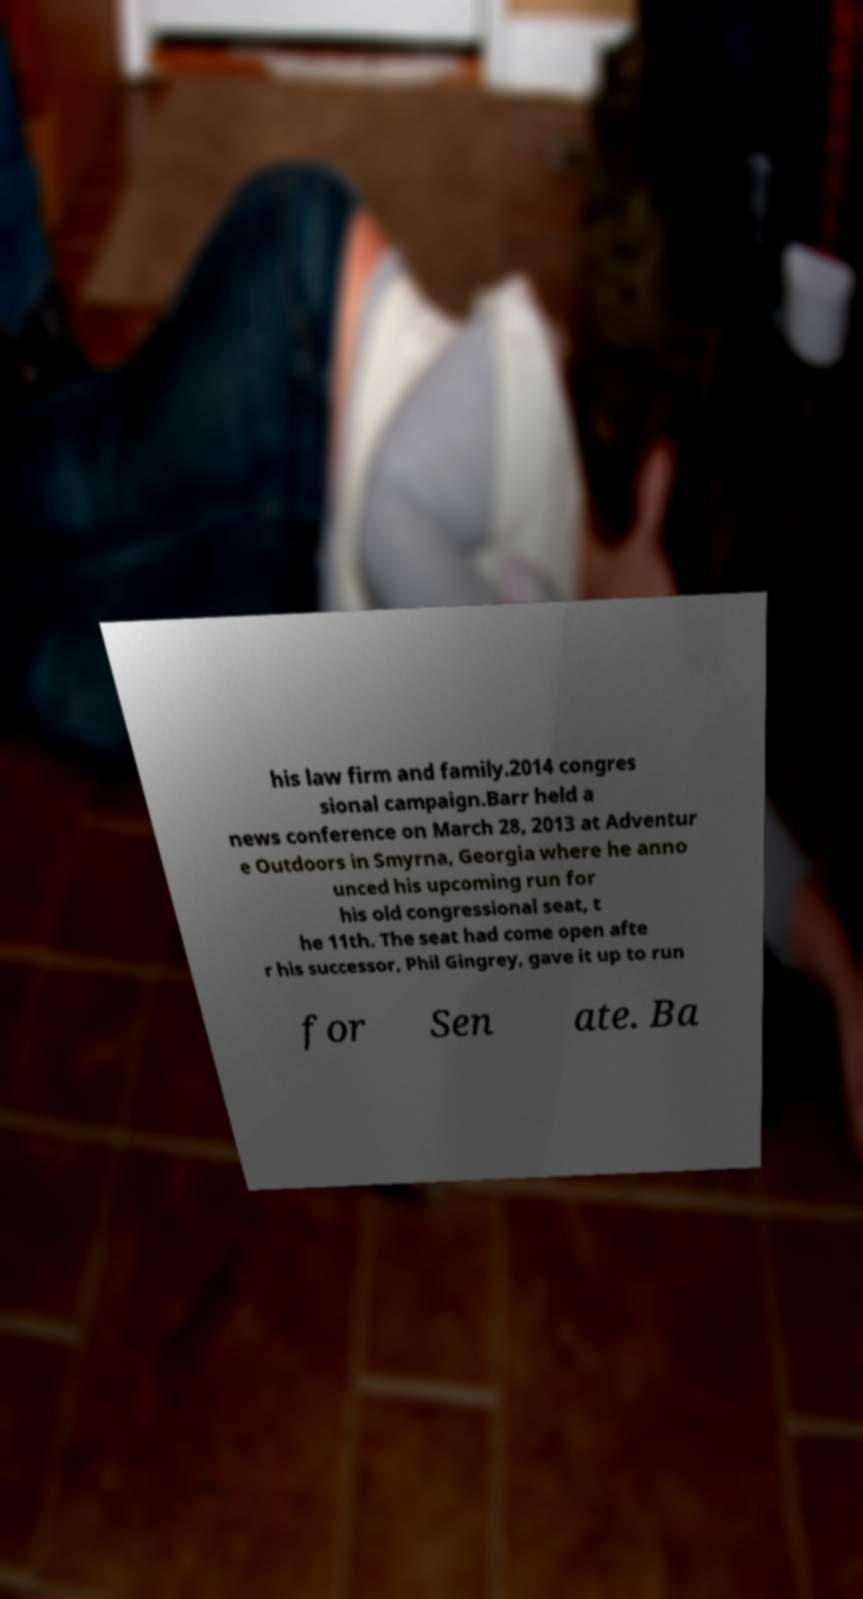Can you accurately transcribe the text from the provided image for me? his law firm and family.2014 congres sional campaign.Barr held a news conference on March 28, 2013 at Adventur e Outdoors in Smyrna, Georgia where he anno unced his upcoming run for his old congressional seat, t he 11th. The seat had come open afte r his successor, Phil Gingrey, gave it up to run for Sen ate. Ba 